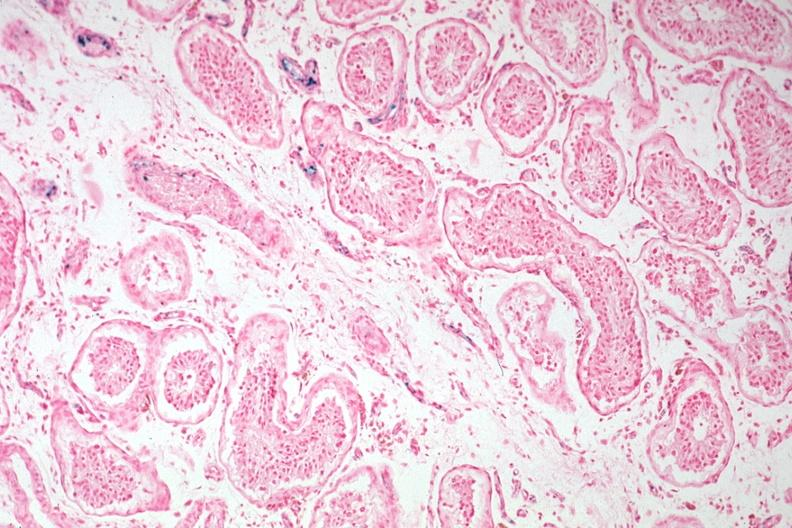s hemochromatosis present?
Answer the question using a single word or phrase. Yes 